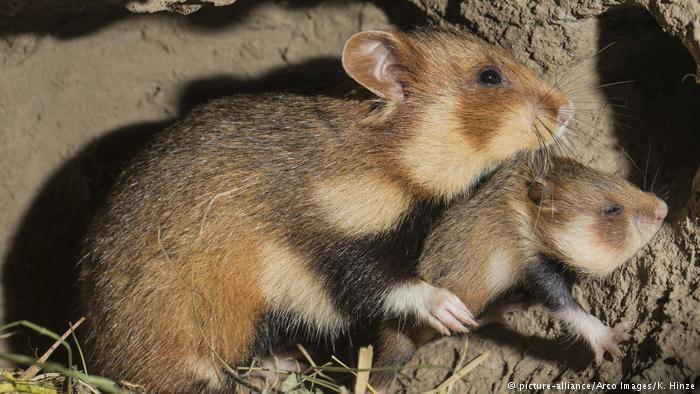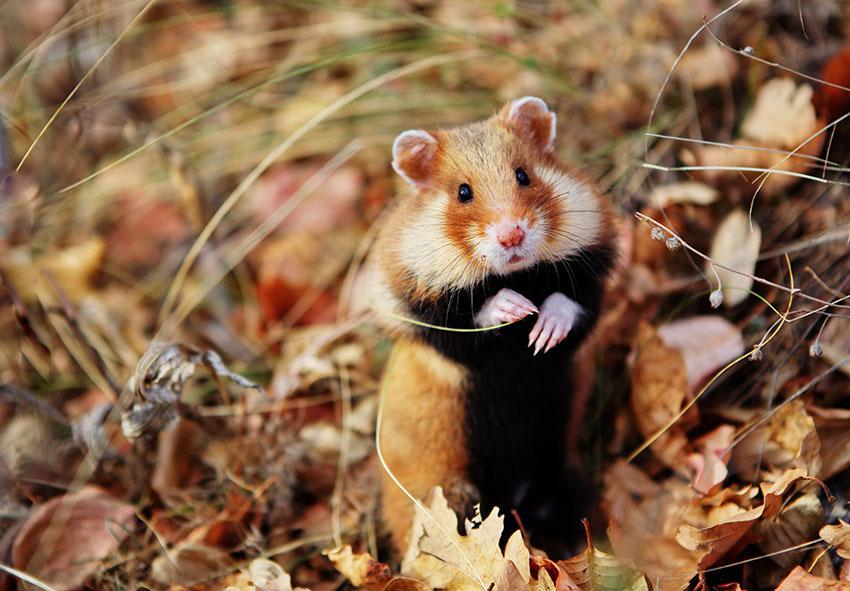The first image is the image on the left, the second image is the image on the right. Assess this claim about the two images: "The left photo contains multiple animals.". Correct or not? Answer yes or no. Yes. The first image is the image on the left, the second image is the image on the right. Examine the images to the left and right. Is the description "The animal in the image on the right is in an upright vertical position on its hind legs." accurate? Answer yes or no. Yes. 